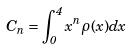<formula> <loc_0><loc_0><loc_500><loc_500>C _ { n } = \int _ { 0 } ^ { 4 } x ^ { n } \rho ( x ) d x</formula> 